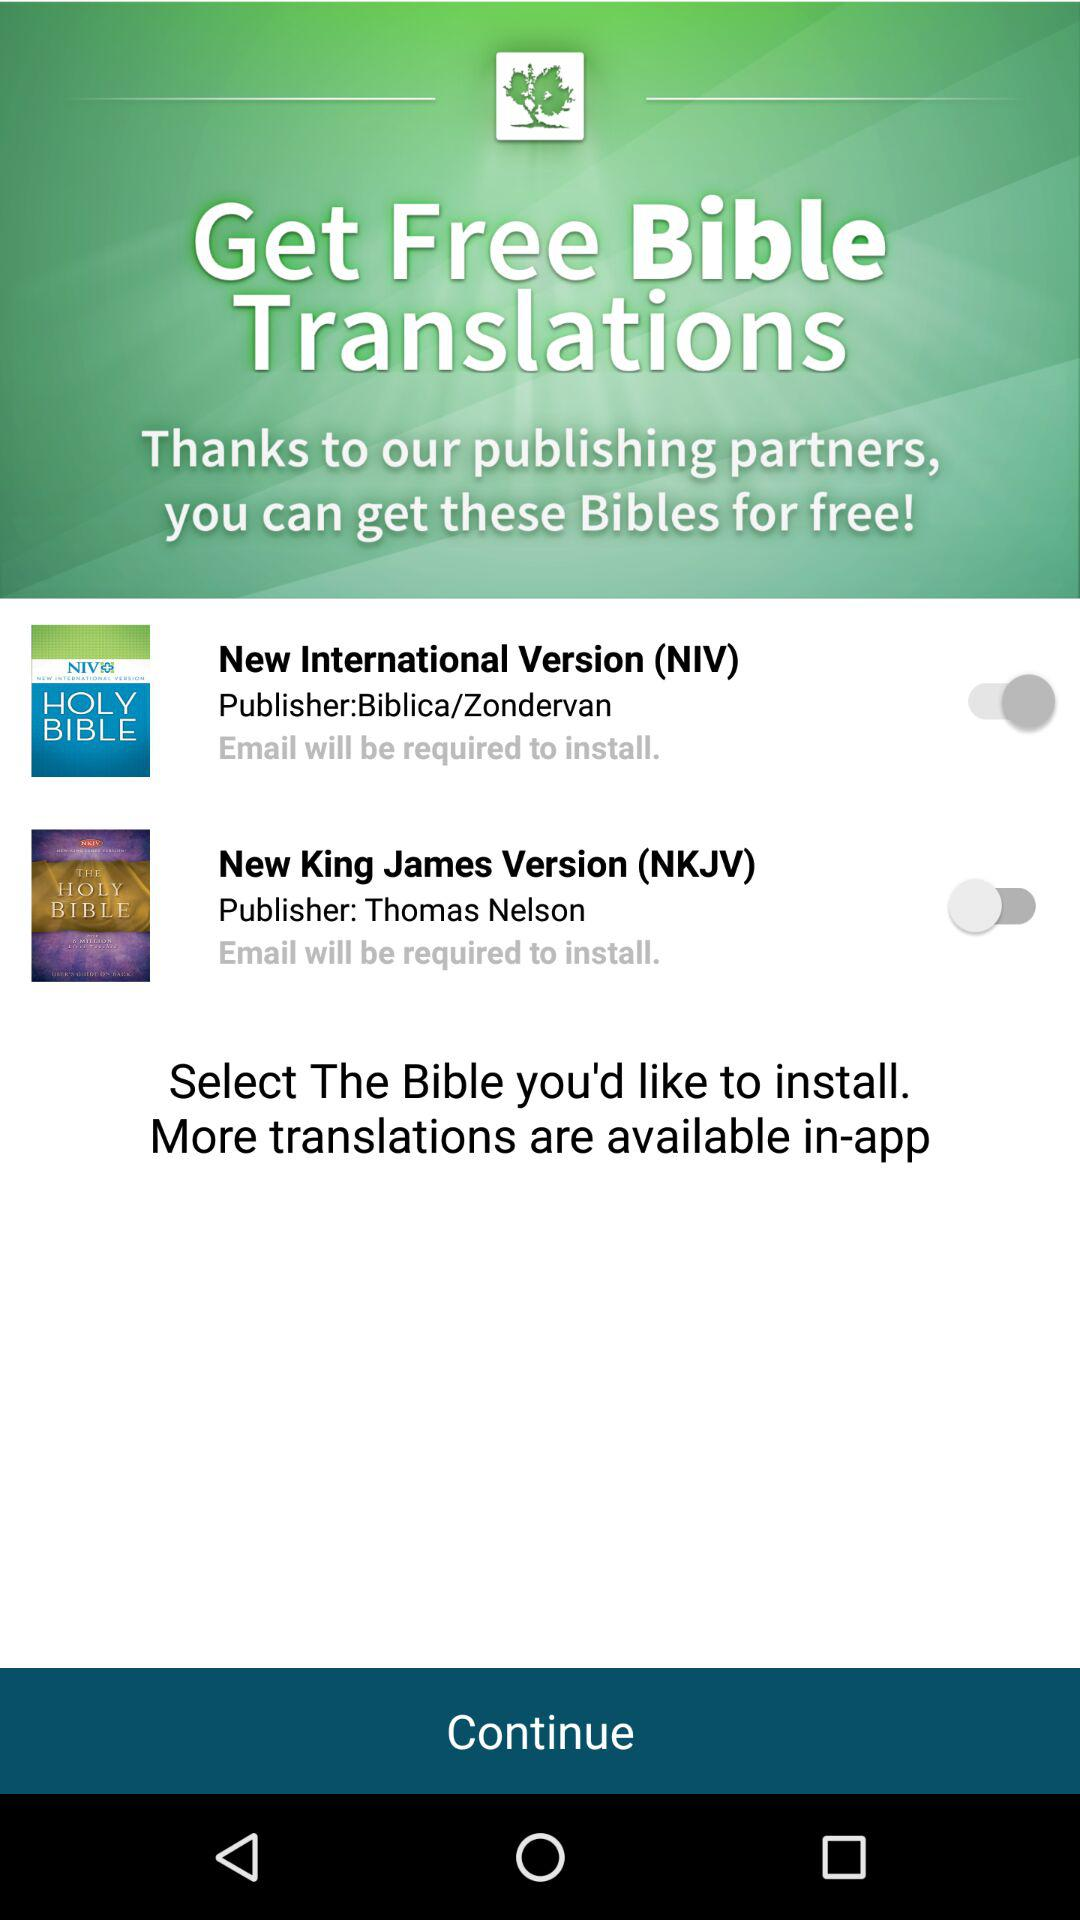Who is the publisher of the "New International Version"? The publisher of the "New International Version" is "Biblica/Zondervan". 